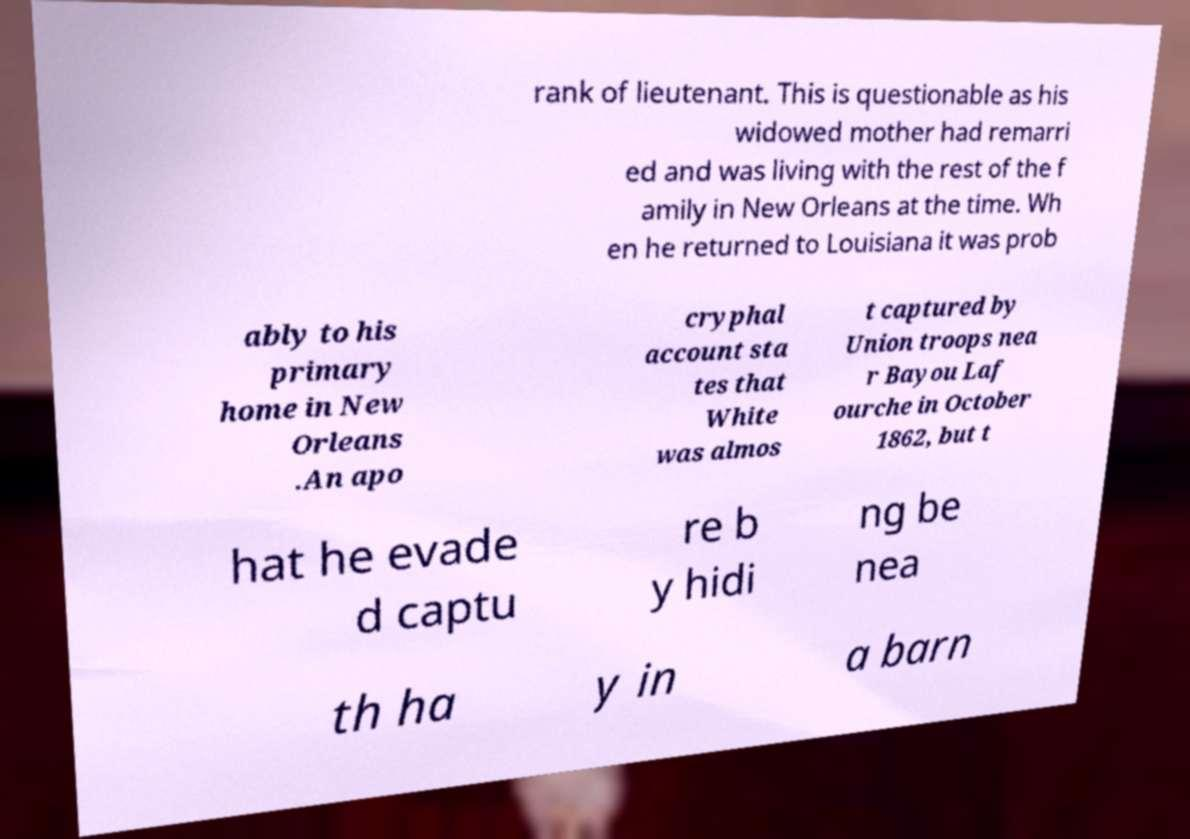Can you accurately transcribe the text from the provided image for me? rank of lieutenant. This is questionable as his widowed mother had remarri ed and was living with the rest of the f amily in New Orleans at the time. Wh en he returned to Louisiana it was prob ably to his primary home in New Orleans .An apo cryphal account sta tes that White was almos t captured by Union troops nea r Bayou Laf ourche in October 1862, but t hat he evade d captu re b y hidi ng be nea th ha y in a barn 